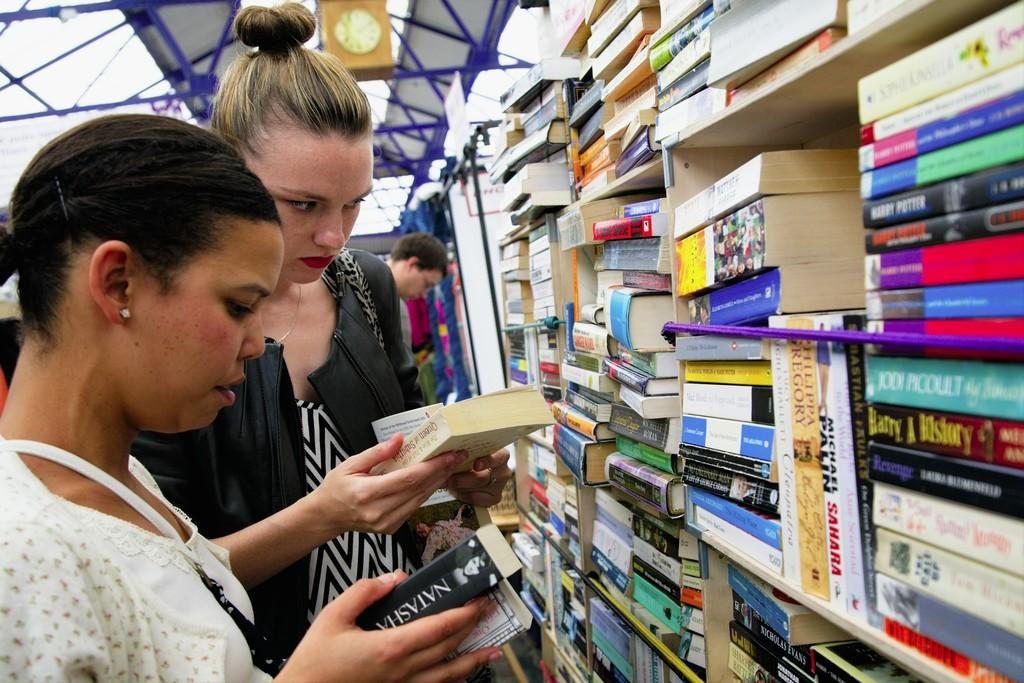<image>
Offer a succinct explanation of the picture presented. Two ladies looking at books one of the books says Natasha on it. 